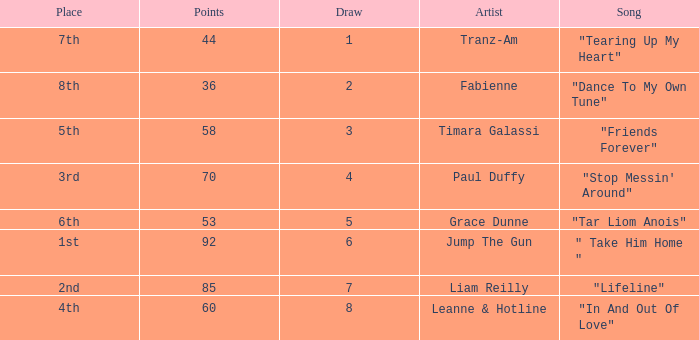What's the song of artist liam reilly? "Lifeline". 